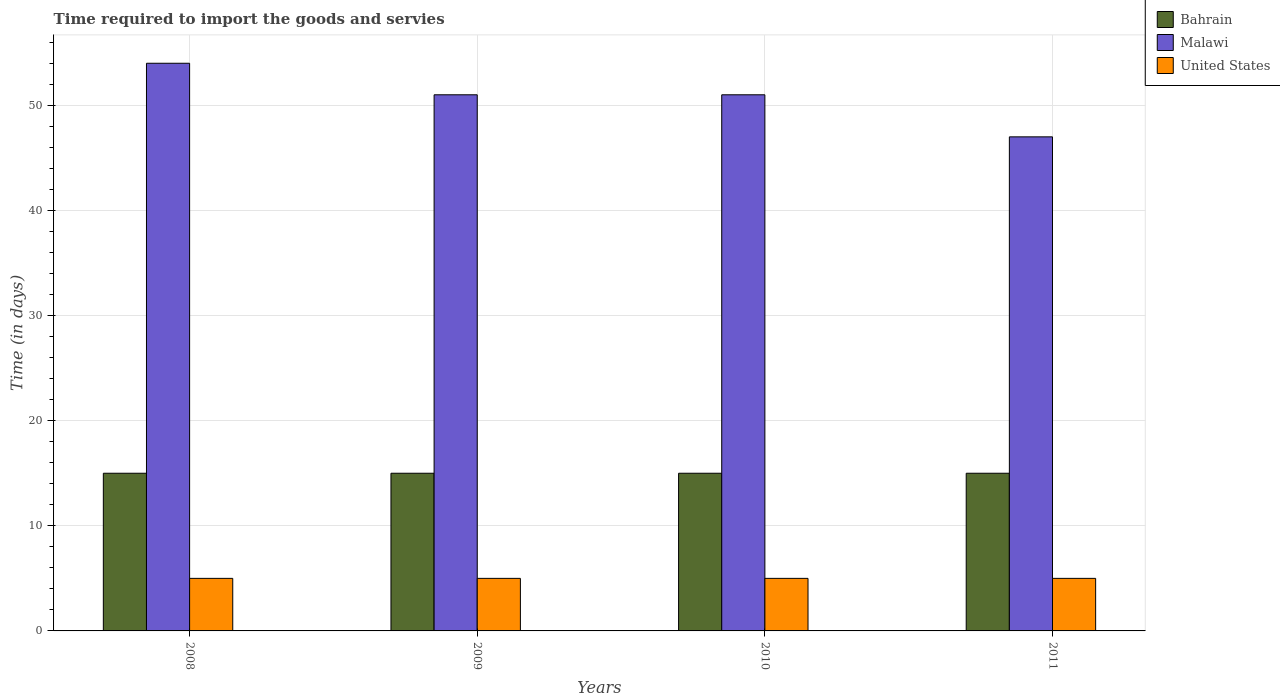How many groups of bars are there?
Give a very brief answer. 4. Are the number of bars on each tick of the X-axis equal?
Your answer should be compact. Yes. How many bars are there on the 4th tick from the right?
Offer a terse response. 3. What is the label of the 3rd group of bars from the left?
Keep it short and to the point. 2010. In how many cases, is the number of bars for a given year not equal to the number of legend labels?
Provide a short and direct response. 0. What is the number of days required to import the goods and services in Malawi in 2008?
Offer a very short reply. 54. Across all years, what is the maximum number of days required to import the goods and services in Malawi?
Your response must be concise. 54. In which year was the number of days required to import the goods and services in United States minimum?
Provide a short and direct response. 2008. What is the total number of days required to import the goods and services in United States in the graph?
Ensure brevity in your answer.  20. What is the difference between the number of days required to import the goods and services in Malawi in 2008 and that in 2011?
Offer a very short reply. 7. What is the average number of days required to import the goods and services in Malawi per year?
Your answer should be compact. 50.75. In the year 2010, what is the difference between the number of days required to import the goods and services in United States and number of days required to import the goods and services in Malawi?
Provide a succinct answer. -46. In how many years, is the number of days required to import the goods and services in United States greater than 38 days?
Offer a very short reply. 0. What is the ratio of the number of days required to import the goods and services in United States in 2010 to that in 2011?
Your answer should be compact. 1. Is the number of days required to import the goods and services in Malawi in 2008 less than that in 2011?
Your answer should be very brief. No. What is the difference between the highest and the second highest number of days required to import the goods and services in United States?
Offer a very short reply. 0. What is the difference between the highest and the lowest number of days required to import the goods and services in Bahrain?
Your answer should be very brief. 0. In how many years, is the number of days required to import the goods and services in Bahrain greater than the average number of days required to import the goods and services in Bahrain taken over all years?
Ensure brevity in your answer.  0. What does the 1st bar from the left in 2011 represents?
Your answer should be compact. Bahrain. What does the 2nd bar from the right in 2008 represents?
Your response must be concise. Malawi. How many years are there in the graph?
Ensure brevity in your answer.  4. Where does the legend appear in the graph?
Offer a terse response. Top right. How are the legend labels stacked?
Keep it short and to the point. Vertical. What is the title of the graph?
Ensure brevity in your answer.  Time required to import the goods and servies. Does "Bosnia and Herzegovina" appear as one of the legend labels in the graph?
Your response must be concise. No. What is the label or title of the Y-axis?
Make the answer very short. Time (in days). What is the Time (in days) of Bahrain in 2008?
Give a very brief answer. 15. What is the Time (in days) of Malawi in 2009?
Your answer should be compact. 51. What is the Time (in days) in United States in 2009?
Keep it short and to the point. 5. What is the Time (in days) of Bahrain in 2010?
Your response must be concise. 15. What is the Time (in days) of Malawi in 2010?
Make the answer very short. 51. What is the Time (in days) of United States in 2011?
Give a very brief answer. 5. Across all years, what is the maximum Time (in days) of Bahrain?
Offer a very short reply. 15. Across all years, what is the maximum Time (in days) in Malawi?
Provide a short and direct response. 54. Across all years, what is the maximum Time (in days) in United States?
Offer a very short reply. 5. What is the total Time (in days) in Malawi in the graph?
Your answer should be very brief. 203. What is the difference between the Time (in days) of Bahrain in 2008 and that in 2010?
Provide a short and direct response. 0. What is the difference between the Time (in days) of Malawi in 2008 and that in 2011?
Offer a terse response. 7. What is the difference between the Time (in days) in Malawi in 2009 and that in 2010?
Provide a succinct answer. 0. What is the difference between the Time (in days) of Bahrain in 2009 and that in 2011?
Keep it short and to the point. 0. What is the difference between the Time (in days) in Malawi in 2009 and that in 2011?
Keep it short and to the point. 4. What is the difference between the Time (in days) in United States in 2009 and that in 2011?
Ensure brevity in your answer.  0. What is the difference between the Time (in days) of Bahrain in 2010 and that in 2011?
Provide a succinct answer. 0. What is the difference between the Time (in days) of Bahrain in 2008 and the Time (in days) of Malawi in 2009?
Provide a short and direct response. -36. What is the difference between the Time (in days) in Malawi in 2008 and the Time (in days) in United States in 2009?
Your response must be concise. 49. What is the difference between the Time (in days) in Bahrain in 2008 and the Time (in days) in Malawi in 2010?
Your response must be concise. -36. What is the difference between the Time (in days) in Malawi in 2008 and the Time (in days) in United States in 2010?
Provide a succinct answer. 49. What is the difference between the Time (in days) of Bahrain in 2008 and the Time (in days) of Malawi in 2011?
Make the answer very short. -32. What is the difference between the Time (in days) of Bahrain in 2008 and the Time (in days) of United States in 2011?
Provide a succinct answer. 10. What is the difference between the Time (in days) of Malawi in 2008 and the Time (in days) of United States in 2011?
Ensure brevity in your answer.  49. What is the difference between the Time (in days) of Bahrain in 2009 and the Time (in days) of Malawi in 2010?
Keep it short and to the point. -36. What is the difference between the Time (in days) of Bahrain in 2009 and the Time (in days) of Malawi in 2011?
Make the answer very short. -32. What is the difference between the Time (in days) of Bahrain in 2010 and the Time (in days) of Malawi in 2011?
Your answer should be very brief. -32. What is the difference between the Time (in days) of Bahrain in 2010 and the Time (in days) of United States in 2011?
Ensure brevity in your answer.  10. What is the average Time (in days) in Malawi per year?
Make the answer very short. 50.75. In the year 2008, what is the difference between the Time (in days) in Bahrain and Time (in days) in Malawi?
Your answer should be compact. -39. In the year 2008, what is the difference between the Time (in days) in Bahrain and Time (in days) in United States?
Provide a short and direct response. 10. In the year 2009, what is the difference between the Time (in days) in Bahrain and Time (in days) in Malawi?
Your response must be concise. -36. In the year 2010, what is the difference between the Time (in days) in Bahrain and Time (in days) in Malawi?
Your answer should be compact. -36. In the year 2010, what is the difference between the Time (in days) of Bahrain and Time (in days) of United States?
Offer a very short reply. 10. In the year 2010, what is the difference between the Time (in days) in Malawi and Time (in days) in United States?
Make the answer very short. 46. In the year 2011, what is the difference between the Time (in days) in Bahrain and Time (in days) in Malawi?
Offer a terse response. -32. What is the ratio of the Time (in days) of Malawi in 2008 to that in 2009?
Your answer should be very brief. 1.06. What is the ratio of the Time (in days) in United States in 2008 to that in 2009?
Provide a short and direct response. 1. What is the ratio of the Time (in days) of Malawi in 2008 to that in 2010?
Offer a terse response. 1.06. What is the ratio of the Time (in days) in Bahrain in 2008 to that in 2011?
Give a very brief answer. 1. What is the ratio of the Time (in days) in Malawi in 2008 to that in 2011?
Your answer should be very brief. 1.15. What is the ratio of the Time (in days) of Bahrain in 2009 to that in 2010?
Make the answer very short. 1. What is the ratio of the Time (in days) of United States in 2009 to that in 2010?
Offer a very short reply. 1. What is the ratio of the Time (in days) in Bahrain in 2009 to that in 2011?
Provide a short and direct response. 1. What is the ratio of the Time (in days) of Malawi in 2009 to that in 2011?
Your answer should be compact. 1.09. What is the ratio of the Time (in days) in Bahrain in 2010 to that in 2011?
Provide a succinct answer. 1. What is the ratio of the Time (in days) of Malawi in 2010 to that in 2011?
Your answer should be very brief. 1.09. What is the difference between the highest and the lowest Time (in days) of Bahrain?
Your answer should be compact. 0. What is the difference between the highest and the lowest Time (in days) in United States?
Provide a succinct answer. 0. 